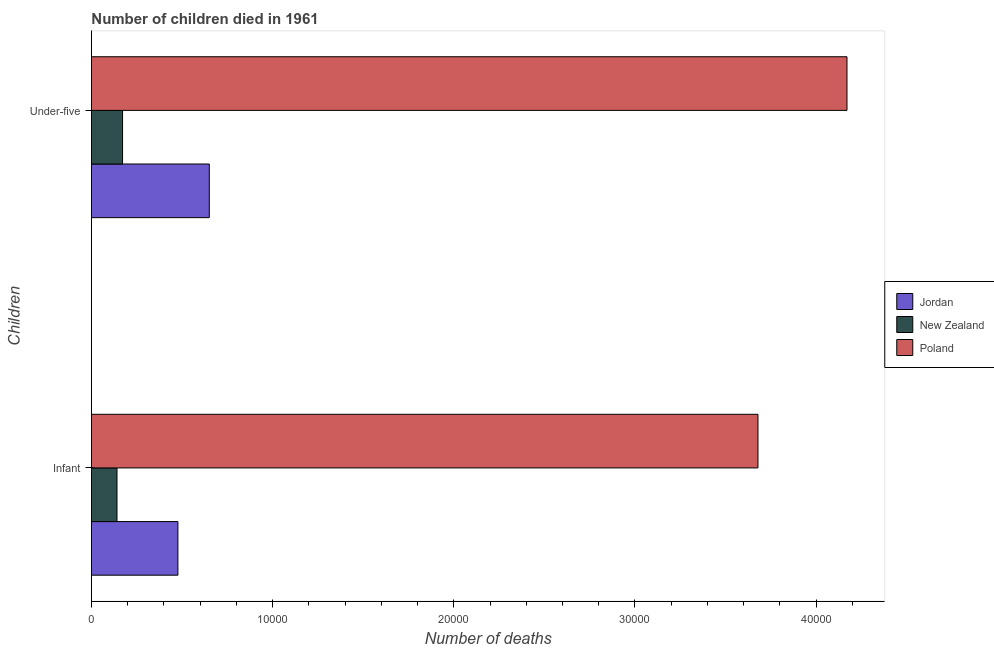How many groups of bars are there?
Your answer should be compact. 2. Are the number of bars on each tick of the Y-axis equal?
Your answer should be very brief. Yes. How many bars are there on the 1st tick from the top?
Offer a terse response. 3. How many bars are there on the 2nd tick from the bottom?
Provide a short and direct response. 3. What is the label of the 2nd group of bars from the top?
Give a very brief answer. Infant. What is the number of infant deaths in New Zealand?
Your answer should be compact. 1412. Across all countries, what is the maximum number of under-five deaths?
Give a very brief answer. 4.17e+04. Across all countries, what is the minimum number of infant deaths?
Provide a succinct answer. 1412. In which country was the number of infant deaths maximum?
Your response must be concise. Poland. In which country was the number of infant deaths minimum?
Your answer should be very brief. New Zealand. What is the total number of infant deaths in the graph?
Your answer should be compact. 4.30e+04. What is the difference between the number of under-five deaths in Jordan and that in New Zealand?
Keep it short and to the point. 4787. What is the difference between the number of infant deaths in Poland and the number of under-five deaths in Jordan?
Your answer should be compact. 3.03e+04. What is the average number of under-five deaths per country?
Keep it short and to the point. 1.66e+04. What is the difference between the number of under-five deaths and number of infant deaths in Jordan?
Your response must be concise. 1733. What is the ratio of the number of under-five deaths in New Zealand to that in Jordan?
Keep it short and to the point. 0.26. In how many countries, is the number of under-five deaths greater than the average number of under-five deaths taken over all countries?
Your answer should be compact. 1. What does the 2nd bar from the top in Under-five represents?
Keep it short and to the point. New Zealand. What does the 2nd bar from the bottom in Under-five represents?
Provide a succinct answer. New Zealand. How many bars are there?
Make the answer very short. 6. Are all the bars in the graph horizontal?
Make the answer very short. Yes. What is the difference between two consecutive major ticks on the X-axis?
Provide a short and direct response. 10000. Are the values on the major ticks of X-axis written in scientific E-notation?
Offer a very short reply. No. Does the graph contain any zero values?
Your answer should be compact. No. Does the graph contain grids?
Make the answer very short. No. How many legend labels are there?
Your response must be concise. 3. What is the title of the graph?
Offer a very short reply. Number of children died in 1961. What is the label or title of the X-axis?
Offer a terse response. Number of deaths. What is the label or title of the Y-axis?
Provide a short and direct response. Children. What is the Number of deaths of Jordan in Infant?
Your answer should be compact. 4773. What is the Number of deaths of New Zealand in Infant?
Offer a very short reply. 1412. What is the Number of deaths in Poland in Infant?
Your response must be concise. 3.68e+04. What is the Number of deaths in Jordan in Under-five?
Provide a short and direct response. 6506. What is the Number of deaths of New Zealand in Under-five?
Your response must be concise. 1719. What is the Number of deaths of Poland in Under-five?
Make the answer very short. 4.17e+04. Across all Children, what is the maximum Number of deaths in Jordan?
Give a very brief answer. 6506. Across all Children, what is the maximum Number of deaths in New Zealand?
Provide a succinct answer. 1719. Across all Children, what is the maximum Number of deaths in Poland?
Keep it short and to the point. 4.17e+04. Across all Children, what is the minimum Number of deaths of Jordan?
Keep it short and to the point. 4773. Across all Children, what is the minimum Number of deaths of New Zealand?
Ensure brevity in your answer.  1412. Across all Children, what is the minimum Number of deaths of Poland?
Your answer should be very brief. 3.68e+04. What is the total Number of deaths in Jordan in the graph?
Ensure brevity in your answer.  1.13e+04. What is the total Number of deaths of New Zealand in the graph?
Provide a short and direct response. 3131. What is the total Number of deaths in Poland in the graph?
Your answer should be very brief. 7.85e+04. What is the difference between the Number of deaths of Jordan in Infant and that in Under-five?
Provide a succinct answer. -1733. What is the difference between the Number of deaths of New Zealand in Infant and that in Under-five?
Your answer should be compact. -307. What is the difference between the Number of deaths of Poland in Infant and that in Under-five?
Offer a terse response. -4913. What is the difference between the Number of deaths in Jordan in Infant and the Number of deaths in New Zealand in Under-five?
Ensure brevity in your answer.  3054. What is the difference between the Number of deaths of Jordan in Infant and the Number of deaths of Poland in Under-five?
Make the answer very short. -3.69e+04. What is the difference between the Number of deaths of New Zealand in Infant and the Number of deaths of Poland in Under-five?
Your answer should be very brief. -4.03e+04. What is the average Number of deaths in Jordan per Children?
Your answer should be very brief. 5639.5. What is the average Number of deaths of New Zealand per Children?
Your answer should be compact. 1565.5. What is the average Number of deaths of Poland per Children?
Your answer should be very brief. 3.92e+04. What is the difference between the Number of deaths in Jordan and Number of deaths in New Zealand in Infant?
Make the answer very short. 3361. What is the difference between the Number of deaths of Jordan and Number of deaths of Poland in Infant?
Offer a terse response. -3.20e+04. What is the difference between the Number of deaths in New Zealand and Number of deaths in Poland in Infant?
Provide a succinct answer. -3.54e+04. What is the difference between the Number of deaths in Jordan and Number of deaths in New Zealand in Under-five?
Your answer should be compact. 4787. What is the difference between the Number of deaths in Jordan and Number of deaths in Poland in Under-five?
Provide a succinct answer. -3.52e+04. What is the difference between the Number of deaths in New Zealand and Number of deaths in Poland in Under-five?
Provide a short and direct response. -4.00e+04. What is the ratio of the Number of deaths in Jordan in Infant to that in Under-five?
Your response must be concise. 0.73. What is the ratio of the Number of deaths in New Zealand in Infant to that in Under-five?
Keep it short and to the point. 0.82. What is the ratio of the Number of deaths in Poland in Infant to that in Under-five?
Offer a terse response. 0.88. What is the difference between the highest and the second highest Number of deaths of Jordan?
Keep it short and to the point. 1733. What is the difference between the highest and the second highest Number of deaths of New Zealand?
Your answer should be very brief. 307. What is the difference between the highest and the second highest Number of deaths of Poland?
Give a very brief answer. 4913. What is the difference between the highest and the lowest Number of deaths in Jordan?
Give a very brief answer. 1733. What is the difference between the highest and the lowest Number of deaths in New Zealand?
Offer a terse response. 307. What is the difference between the highest and the lowest Number of deaths in Poland?
Provide a succinct answer. 4913. 